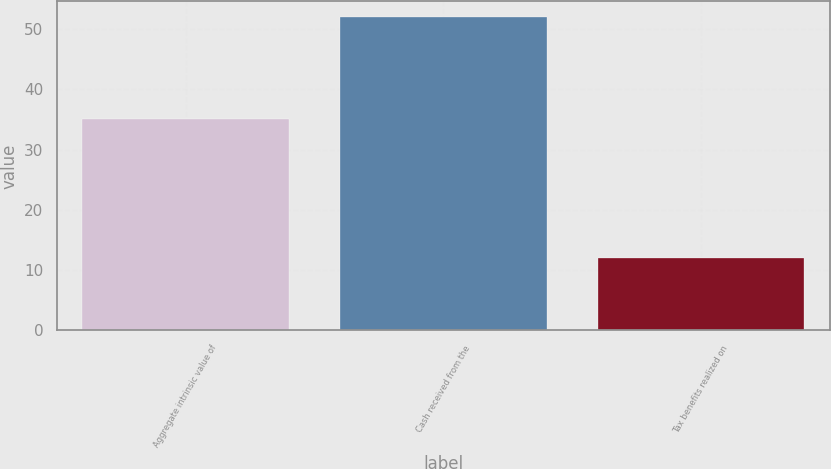<chart> <loc_0><loc_0><loc_500><loc_500><bar_chart><fcel>Aggregate intrinsic value of<fcel>Cash received from the<fcel>Tax benefits realized on<nl><fcel>35<fcel>52<fcel>12<nl></chart> 